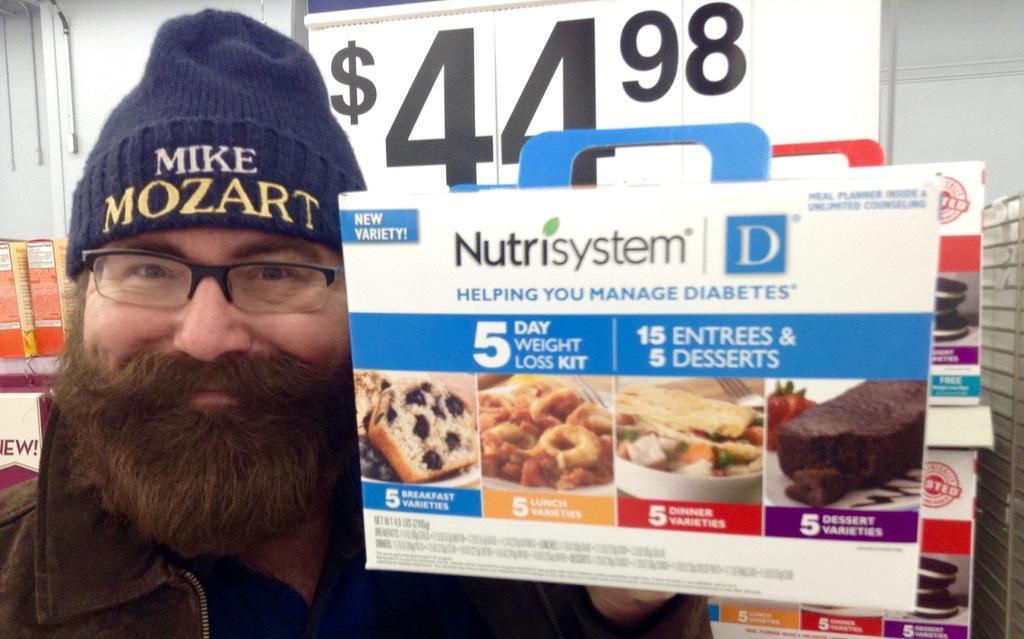Can you describe this image briefly? As we can see in the image there is a man wearing cap, spectacles and holding a banner. There is a white color wall and door. 